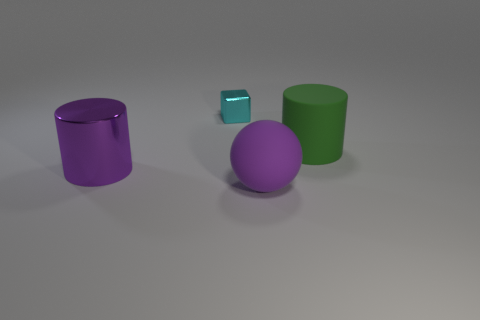Add 1 green objects. How many objects exist? 5 Subtract all spheres. How many objects are left? 3 Subtract 0 purple cubes. How many objects are left? 4 Subtract all cyan metal spheres. Subtract all balls. How many objects are left? 3 Add 3 small shiny objects. How many small shiny objects are left? 4 Add 2 green rubber cubes. How many green rubber cubes exist? 2 